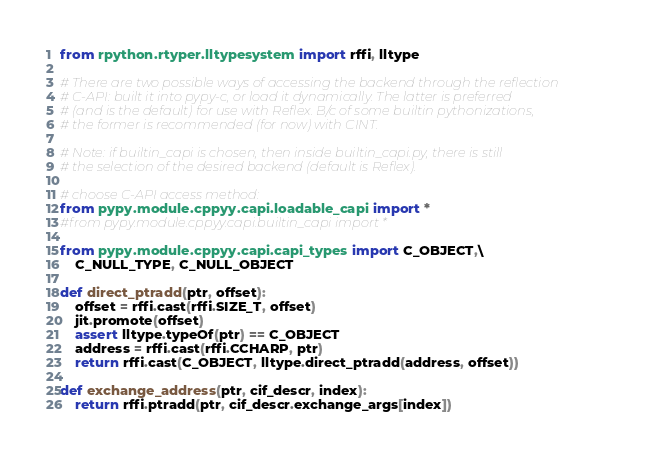<code> <loc_0><loc_0><loc_500><loc_500><_Python_>from rpython.rtyper.lltypesystem import rffi, lltype

# There are two possible ways of accessing the backend through the reflection
# C-API: built it into pypy-c, or load it dynamically. The latter is preferred
# (and is the default) for use with Reflex. B/c of some builtin pythonizations,
# the former is recommended (for now) with CINT.

# Note: if builtin_capi is chosen, then inside builtin_capi.py, there is still
# the selection of the desired backend (default is Reflex).

# choose C-API access method:
from pypy.module.cppyy.capi.loadable_capi import *
#from pypy.module.cppyy.capi.builtin_capi import *

from pypy.module.cppyy.capi.capi_types import C_OBJECT,\
    C_NULL_TYPE, C_NULL_OBJECT

def direct_ptradd(ptr, offset):
    offset = rffi.cast(rffi.SIZE_T, offset)
    jit.promote(offset)
    assert lltype.typeOf(ptr) == C_OBJECT
    address = rffi.cast(rffi.CCHARP, ptr)
    return rffi.cast(C_OBJECT, lltype.direct_ptradd(address, offset))

def exchange_address(ptr, cif_descr, index):
    return rffi.ptradd(ptr, cif_descr.exchange_args[index])
</code> 